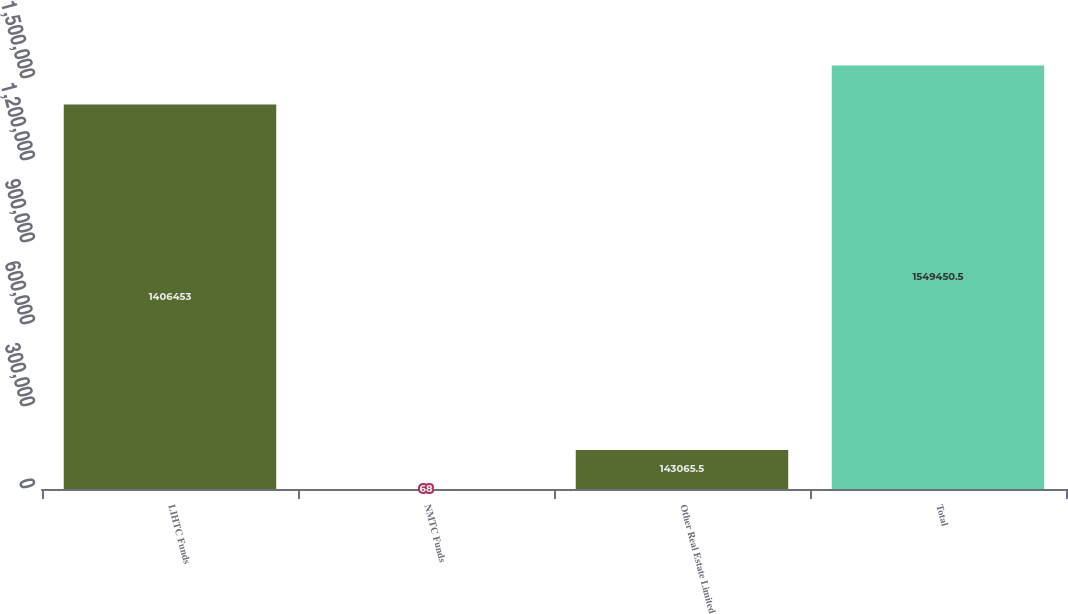Convert chart to OTSL. <chart><loc_0><loc_0><loc_500><loc_500><bar_chart><fcel>LIHTC Funds<fcel>NMTC Funds<fcel>Other Real Estate Limited<fcel>Total<nl><fcel>1.40645e+06<fcel>68<fcel>143066<fcel>1.54945e+06<nl></chart> 